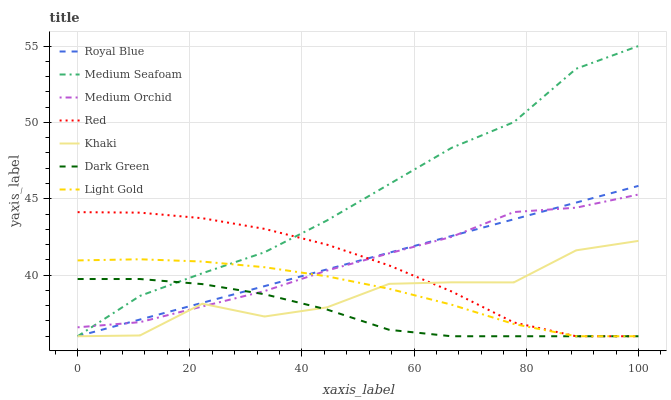Does Dark Green have the minimum area under the curve?
Answer yes or no. Yes. Does Medium Seafoam have the maximum area under the curve?
Answer yes or no. Yes. Does Medium Orchid have the minimum area under the curve?
Answer yes or no. No. Does Medium Orchid have the maximum area under the curve?
Answer yes or no. No. Is Royal Blue the smoothest?
Answer yes or no. Yes. Is Khaki the roughest?
Answer yes or no. Yes. Is Medium Orchid the smoothest?
Answer yes or no. No. Is Medium Orchid the roughest?
Answer yes or no. No. Does Khaki have the lowest value?
Answer yes or no. Yes. Does Medium Orchid have the lowest value?
Answer yes or no. No. Does Medium Seafoam have the highest value?
Answer yes or no. Yes. Does Medium Orchid have the highest value?
Answer yes or no. No. Does Red intersect Light Gold?
Answer yes or no. Yes. Is Red less than Light Gold?
Answer yes or no. No. Is Red greater than Light Gold?
Answer yes or no. No. 